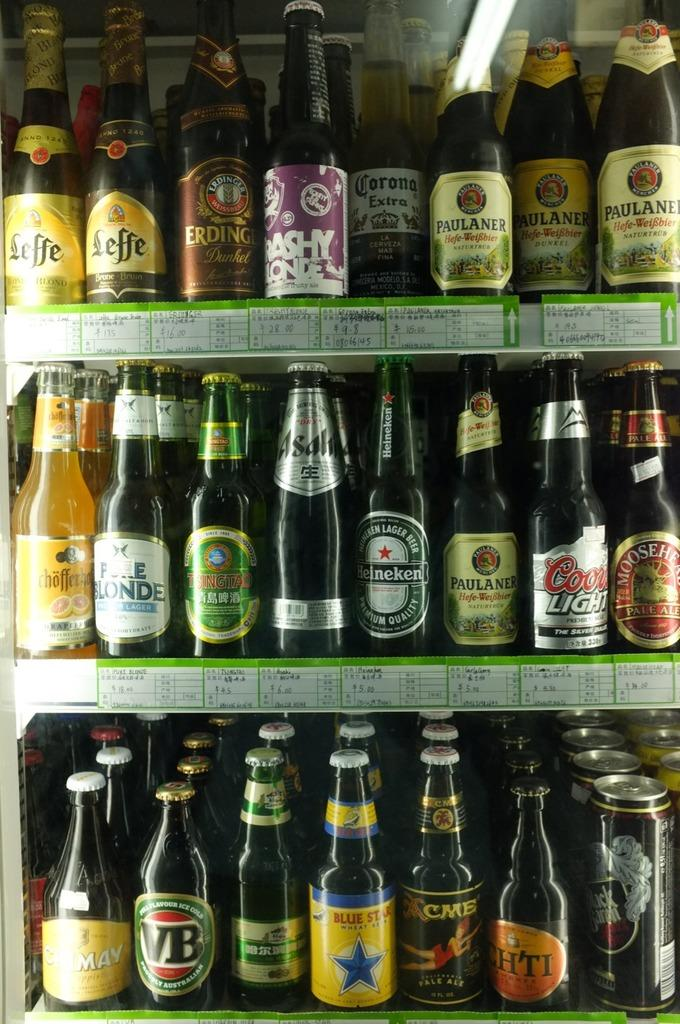<image>
Write a terse but informative summary of the picture. A collection of imported beers on shelves in a refrigerator. 